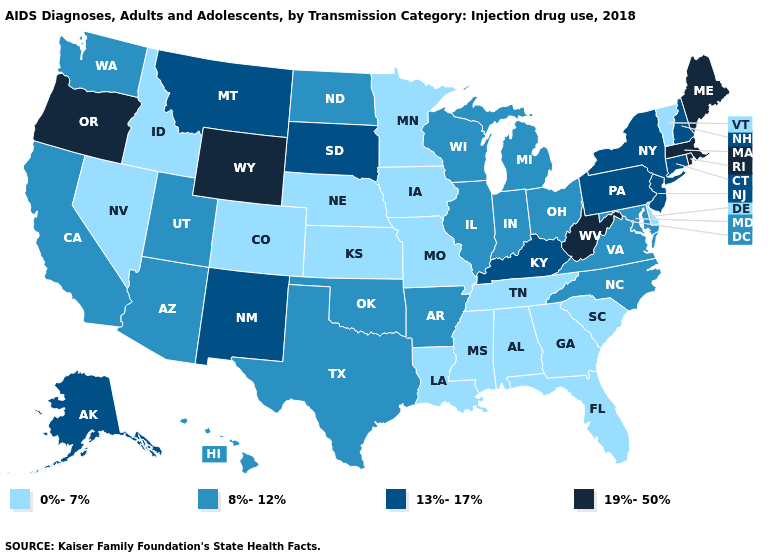Does Rhode Island have the highest value in the USA?
Concise answer only. Yes. What is the lowest value in the USA?
Short answer required. 0%-7%. Name the states that have a value in the range 13%-17%?
Quick response, please. Alaska, Connecticut, Kentucky, Montana, New Hampshire, New Jersey, New Mexico, New York, Pennsylvania, South Dakota. Name the states that have a value in the range 19%-50%?
Answer briefly. Maine, Massachusetts, Oregon, Rhode Island, West Virginia, Wyoming. What is the highest value in states that border Oklahoma?
Concise answer only. 13%-17%. What is the lowest value in the USA?
Be succinct. 0%-7%. Does Florida have a higher value than Washington?
Answer briefly. No. Does Tennessee have the lowest value in the South?
Write a very short answer. Yes. Name the states that have a value in the range 0%-7%?
Give a very brief answer. Alabama, Colorado, Delaware, Florida, Georgia, Idaho, Iowa, Kansas, Louisiana, Minnesota, Mississippi, Missouri, Nebraska, Nevada, South Carolina, Tennessee, Vermont. Which states hav the highest value in the MidWest?
Be succinct. South Dakota. Among the states that border Kentucky , which have the highest value?
Concise answer only. West Virginia. Among the states that border South Carolina , does North Carolina have the highest value?
Write a very short answer. Yes. What is the value of Alaska?
Give a very brief answer. 13%-17%. What is the value of Maryland?
Short answer required. 8%-12%. What is the highest value in states that border Georgia?
Give a very brief answer. 8%-12%. 